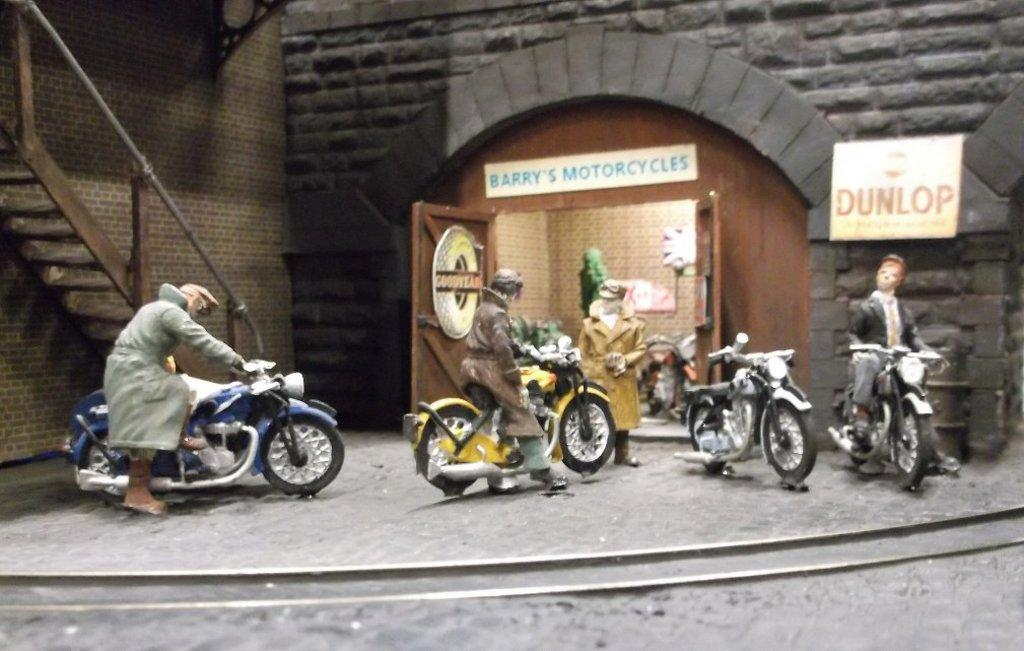What is the main subject of the image? There is a person in the image. What is the person doing in the image? The person is riding a bike. What type of structure is visible in the image? There is a brick wall in the image. Are there any architectural features in the image? Yes, there are stairs in the image. What type of canvas is the person painting on while riding the bike? There is no canvas present in the image, and the person is not painting while riding the bike. 